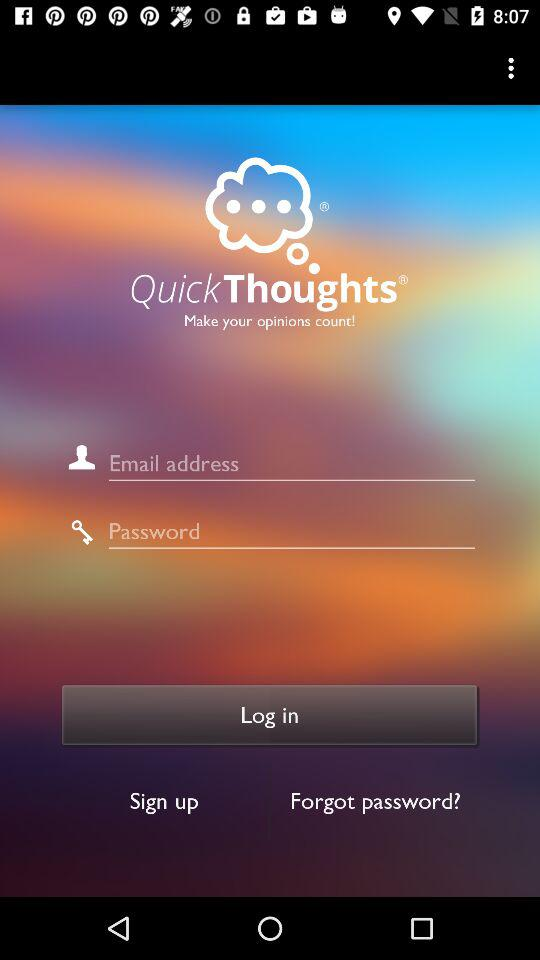What is the app name? The app name is "QuickThoughts". 